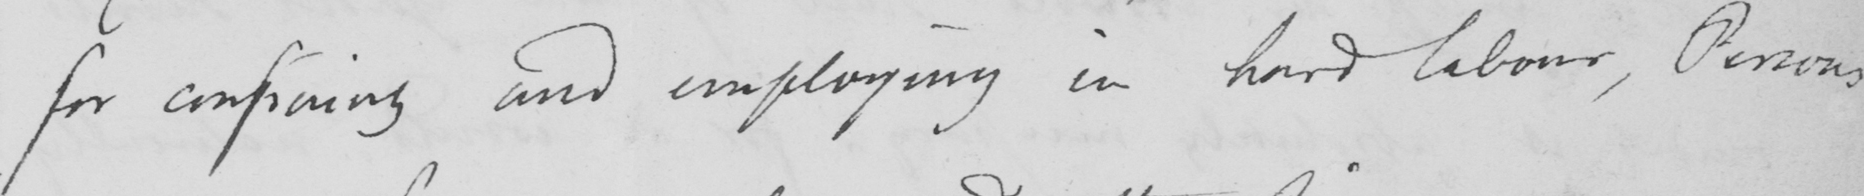Please provide the text content of this handwritten line. for confining and employing in hard labour, Persons 